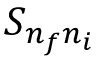Convert formula to latex. <formula><loc_0><loc_0><loc_500><loc_500>S _ { n _ { f } n _ { i } }</formula> 